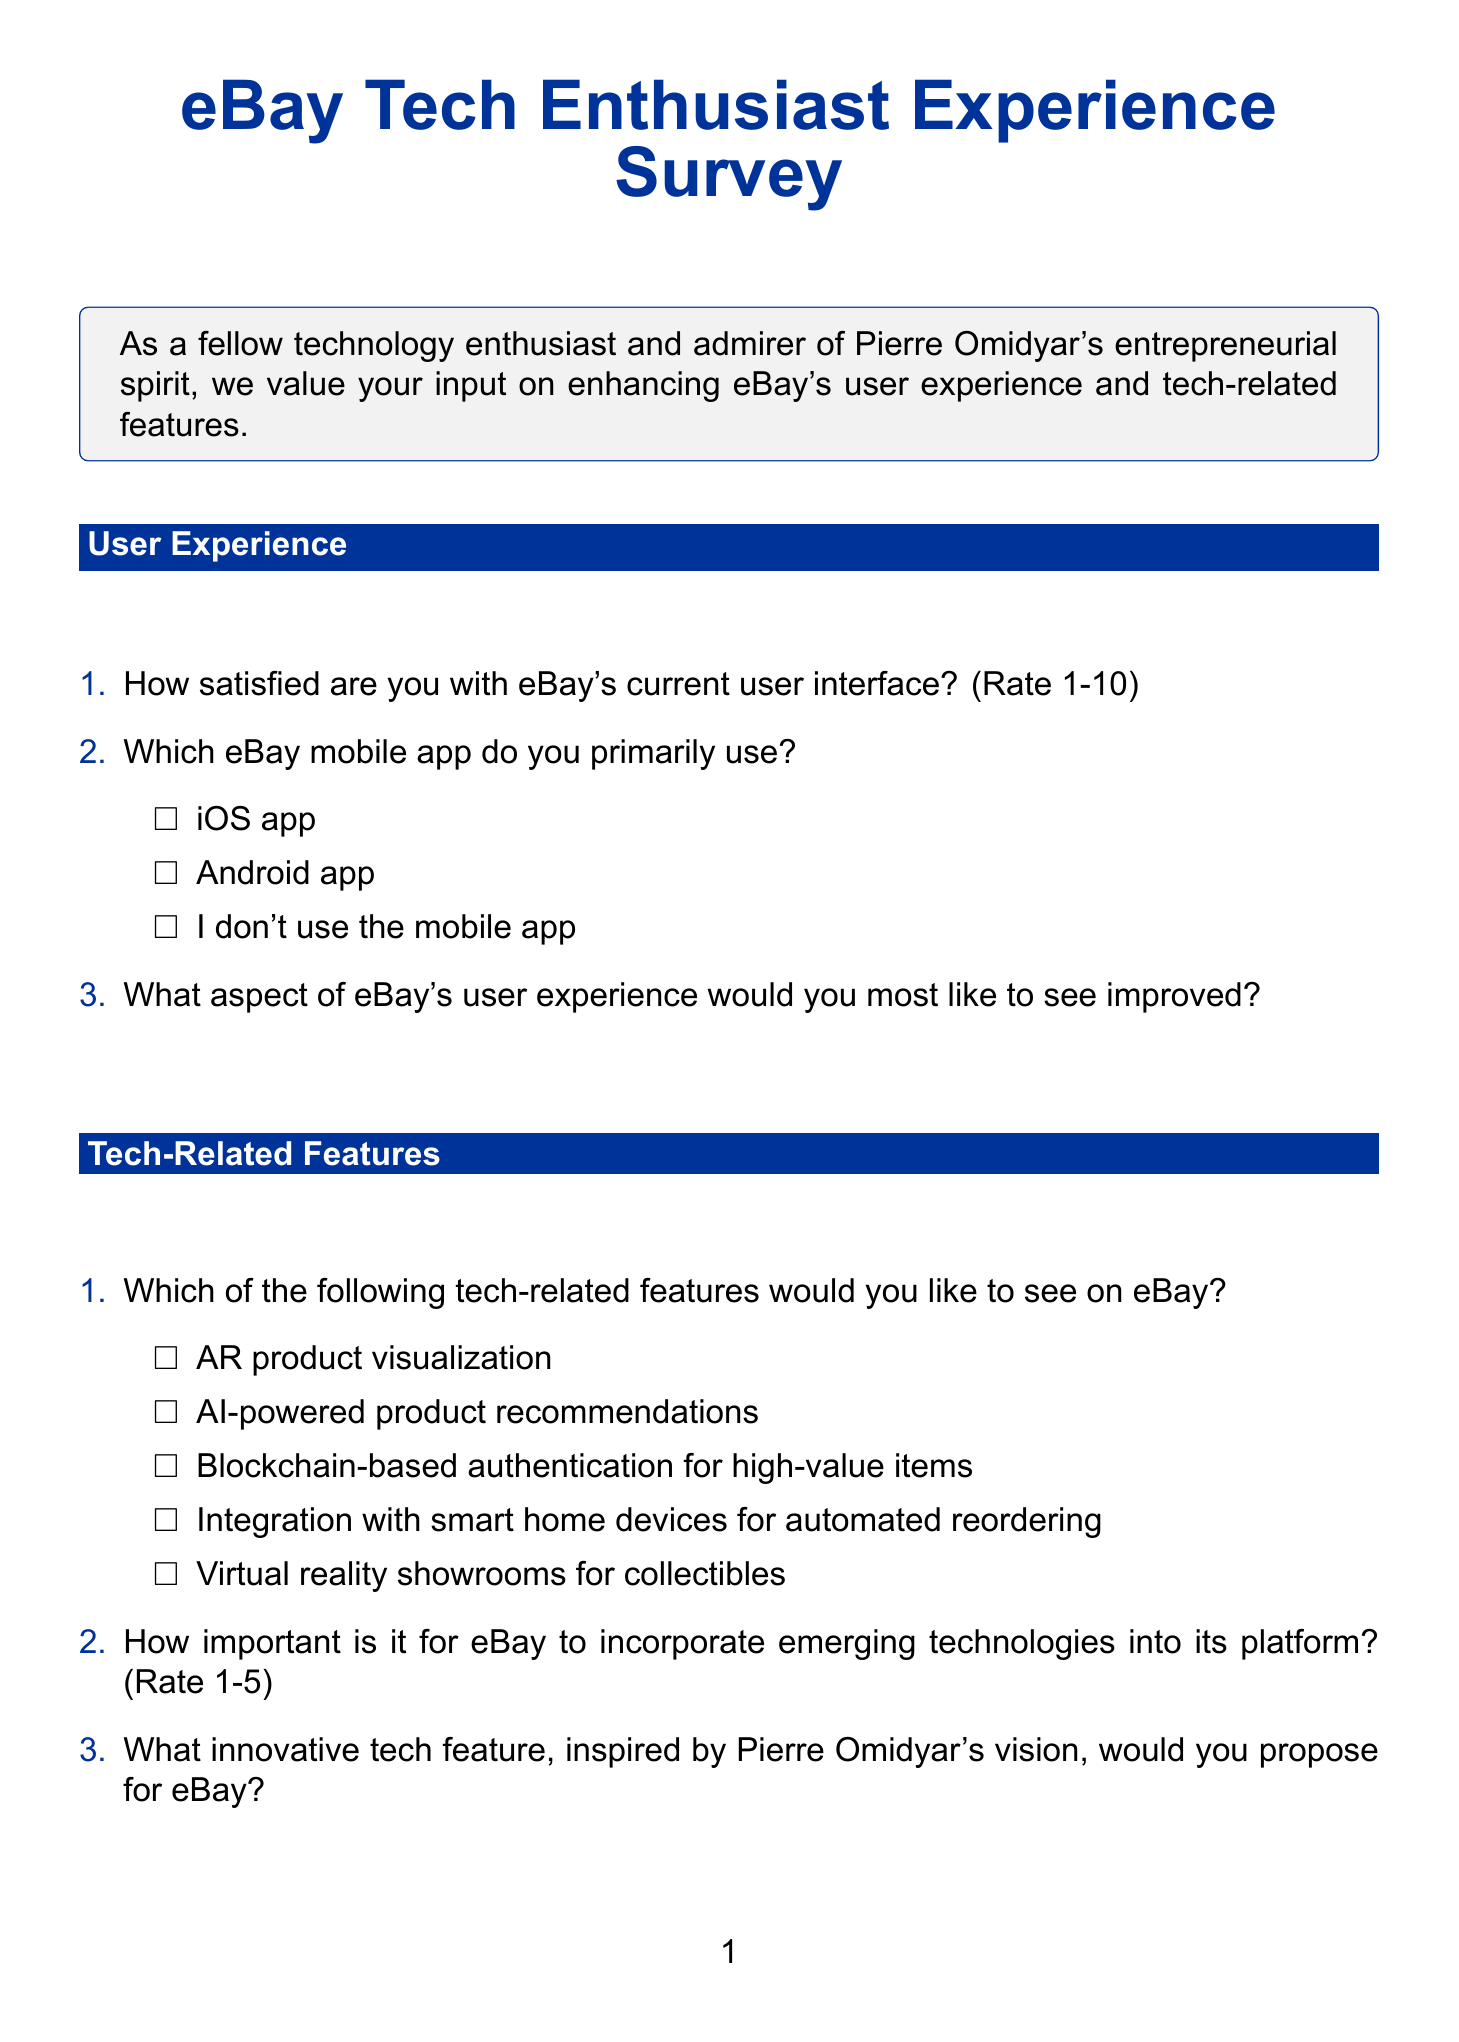What is the title of the survey? The title of the survey is presented at the beginning of the document, clearly stated as eBay Tech Enthusiast Experience Survey.
Answer: eBay Tech Enthusiast Experience Survey How many sections are in the survey? The document lists various sections, and by counting them, we find there are six sections in total.
Answer: 6 What is the scale for rating user interface satisfaction? The document specifies the rating scale for user interface satisfaction as a range from 1 to 10.
Answer: 1-10 Which tech product category is listed as an option for frequent browsing? The document provides multiple-choice options for tech product categories, including smartphones, among others.
Answer: Smartphones What tech-related feature has the highest potential user interest according to the survey? The survey includes various tech-related features; reasoning about user interest would depend on the participant’s choice, but all are listed as options.
Answer: Each feature is an option What is the purpose of the survey as stated in the introduction? The introduction explains that the survey aims to gather input on enhancing eBay's user experience and tech-related features.
Answer: Enhance eBay's user experience and tech-related features What rating scale is used for assessing the value of an eBay-hosted tech enthusiast forum? The document indicates a rating scale of 1 to 5 for assessing the value of a forum for tech enthusiasts.
Answer: 1-5 How does the survey conclude? The conclusion expresses gratitude and emphasizes the importance of feedback in shaping eBay's future.
Answer: Thank you for taking the time to share your insights What type of educational content is queried in the survey? The survey asks for suggestions about the type of tech-related educational content users would like to see from eBay.
Answer: Tech-related educational content 